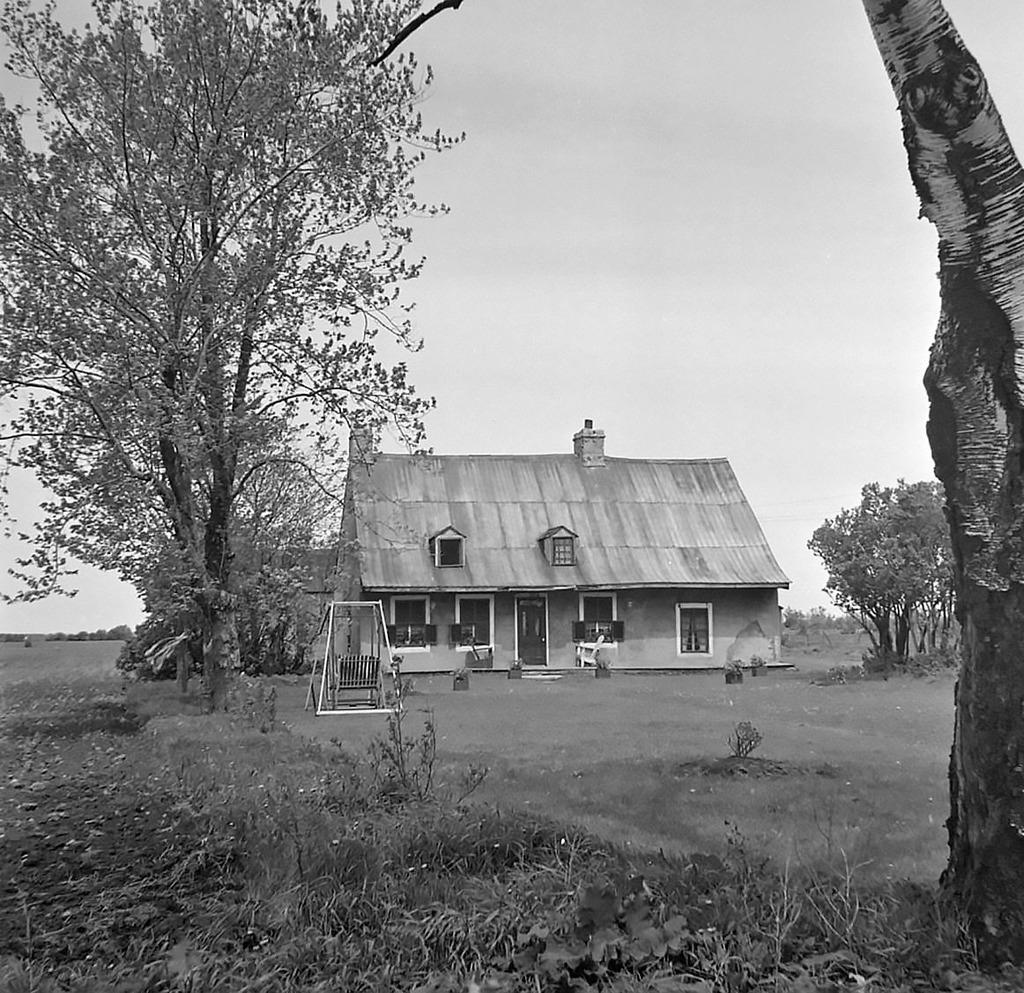What type of structure is present in the image? There is a house in the image. What type of vegetation can be seen in the image? There are trees and grass in the image. What is visible in the background of the image? The sky is visible in the background of the image. What is the color scheme of the image? The image is black and white in color. How does the feeling of the grass change throughout the day in the image? The image is black and white, so it is not possible to determine the feeling of the grass or how it changes throughout the day. 